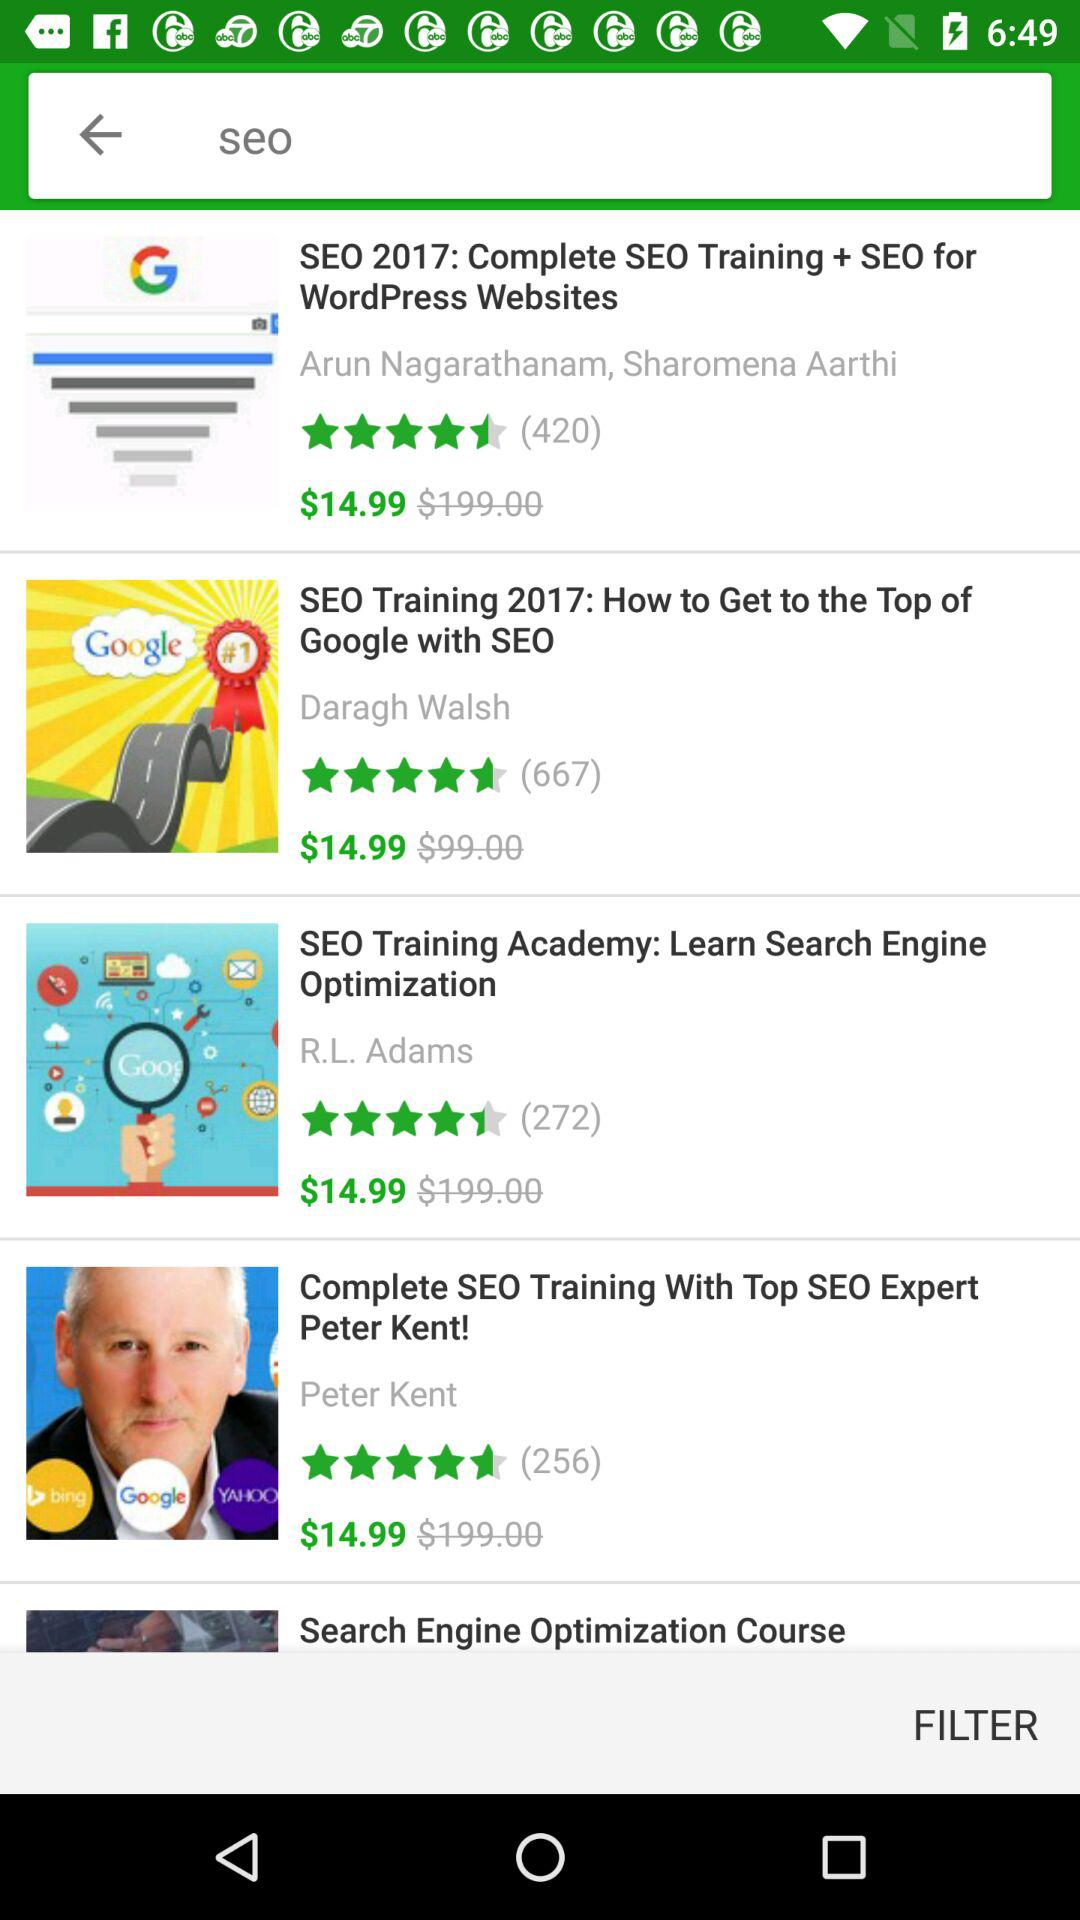How many courses are available for less than $200?
Answer the question using a single word or phrase. 4 